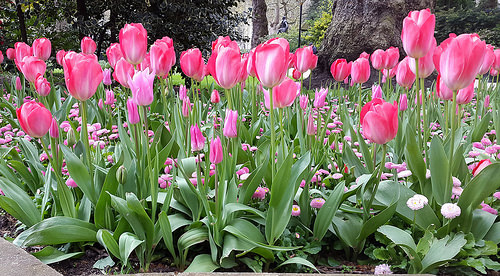<image>
Can you confirm if the flower is above the dirt? Yes. The flower is positioned above the dirt in the vertical space, higher up in the scene. 